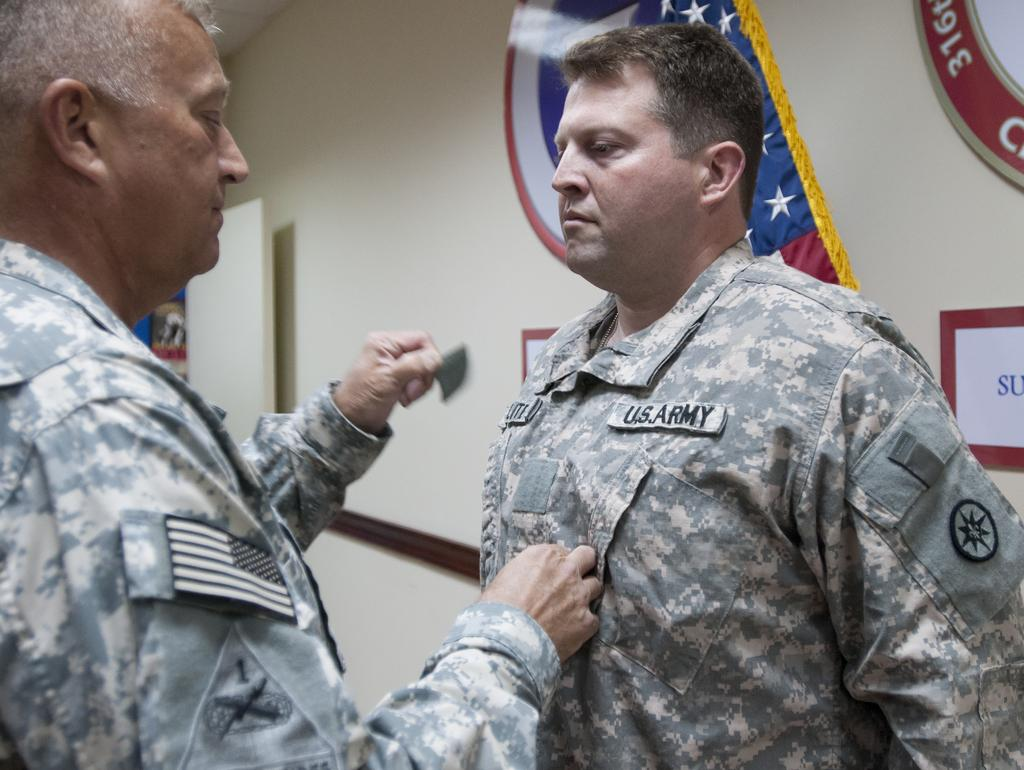How many people are in the image? There are two people in the image. What are the people wearing? The people are wearing military uniforms. What can be seen in the background of the image? There is a cream-colored wall in the background. What is attached to the wall in the image? There are papers attached to the wall. Can you see any rabbits or boats in the image? No, there are no rabbits or boats present in the image. 